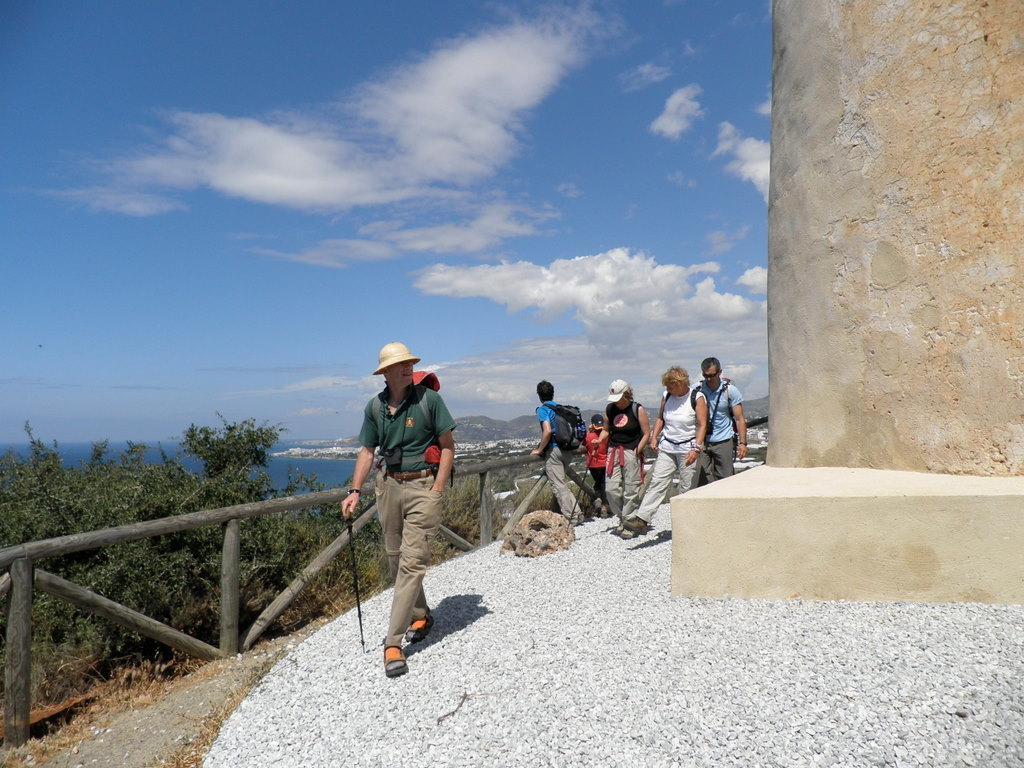In one or two sentences, can you explain what this image depicts? On the left side, there are persons on the concrete road. Beside them, there is a fence. On the right side, there is a wall. In the background, there are trees, there is water, there are mountains and there are clouds in the blue sky. 